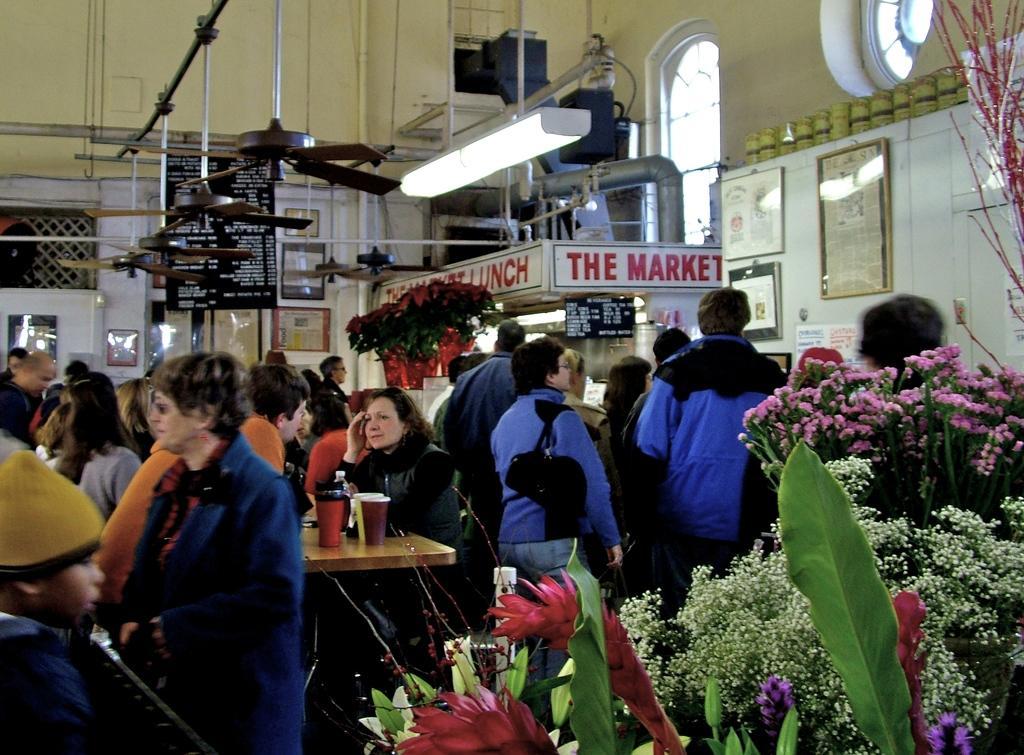Describe this image in one or two sentences. In this image there are group of persons standing, there are persons sitting, there are persons truncated towards the left of the image, there are flowers truncated towards the bottom of the image, there are plants truncated towards the right of the image, there is a table, there are objects on the table, there are fans, there are lights, there are boards, there is text on the boards, there are photo frames, there is wall truncated towards the top of the image, there is wall truncated towards the left of the image, there are objects on the wall, there is wall truncated towards the right of the image. 